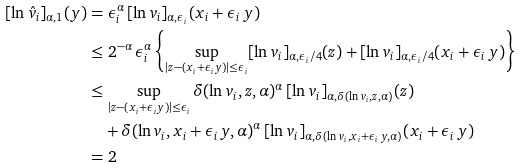<formula> <loc_0><loc_0><loc_500><loc_500>[ \ln \hat { v } _ { i } ] _ { \alpha , 1 } ( y ) & = \epsilon _ { i } ^ { \alpha } \, [ \ln v _ { i } ] _ { \alpha , \epsilon _ { i } } ( x _ { i } + \epsilon _ { i } \, y ) \\ & \leq 2 ^ { - \alpha } \, \epsilon _ { i } ^ { \alpha } \left \{ \sup _ { | z - ( x _ { i } + \epsilon _ { i } y ) | \leq \epsilon _ { i } } [ \ln v _ { i } ] _ { \alpha , \epsilon _ { i } / 4 } ( z ) + [ \ln v _ { i } ] _ { \alpha , \epsilon _ { i } / 4 } ( x _ { i } + \epsilon _ { i } \, y ) \right \} \\ & \leq \sup _ { | z - ( x _ { i } + \epsilon _ { i } y ) | \leq \epsilon _ { i } } \delta ( \ln v _ { i } , z , \alpha ) ^ { \alpha } \, [ \ln v _ { i } ] _ { \alpha , \delta ( \ln v _ { i } , z , \alpha ) } ( z ) \\ & \quad + \delta ( \ln v _ { i } , x _ { i } + \epsilon _ { i } \, y , \alpha ) ^ { \alpha } \, [ \ln v _ { i } ] _ { \alpha , \delta ( \ln v _ { i } , x _ { i } + \epsilon _ { i } \, y , \alpha ) } ( x _ { i } + \epsilon _ { i } \, y ) \\ & = 2</formula> 